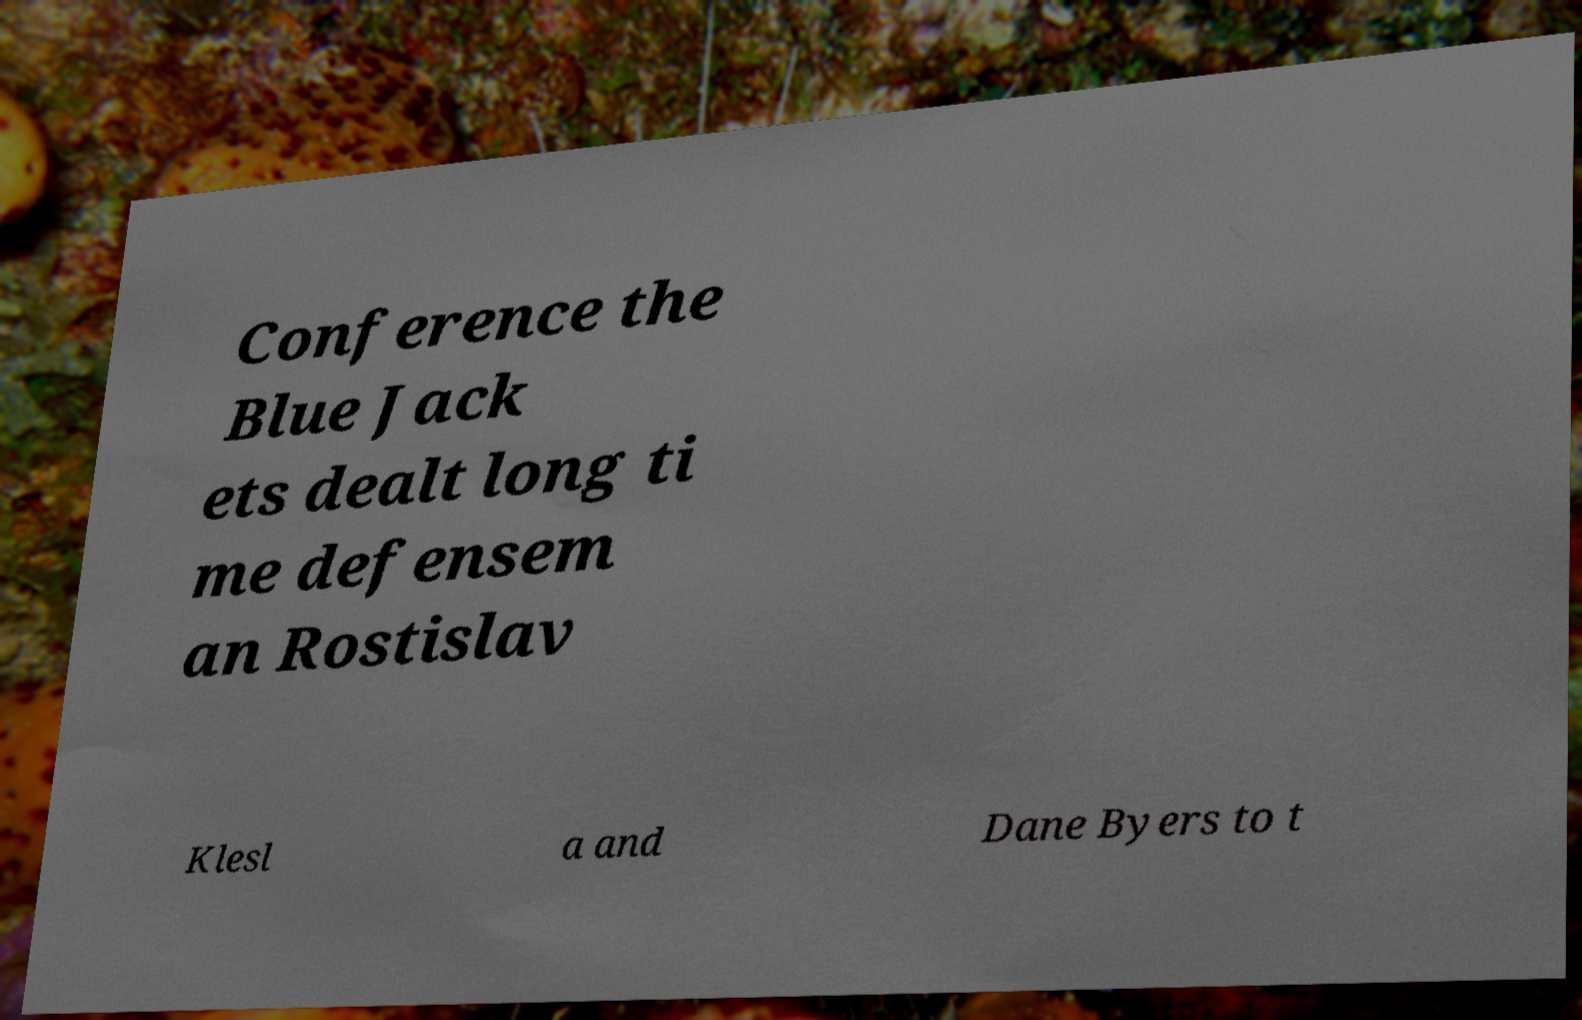Please read and relay the text visible in this image. What does it say? Conference the Blue Jack ets dealt long ti me defensem an Rostislav Klesl a and Dane Byers to t 